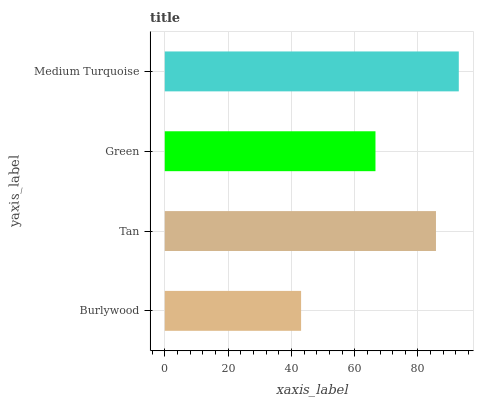Is Burlywood the minimum?
Answer yes or no. Yes. Is Medium Turquoise the maximum?
Answer yes or no. Yes. Is Tan the minimum?
Answer yes or no. No. Is Tan the maximum?
Answer yes or no. No. Is Tan greater than Burlywood?
Answer yes or no. Yes. Is Burlywood less than Tan?
Answer yes or no. Yes. Is Burlywood greater than Tan?
Answer yes or no. No. Is Tan less than Burlywood?
Answer yes or no. No. Is Tan the high median?
Answer yes or no. Yes. Is Green the low median?
Answer yes or no. Yes. Is Burlywood the high median?
Answer yes or no. No. Is Medium Turquoise the low median?
Answer yes or no. No. 